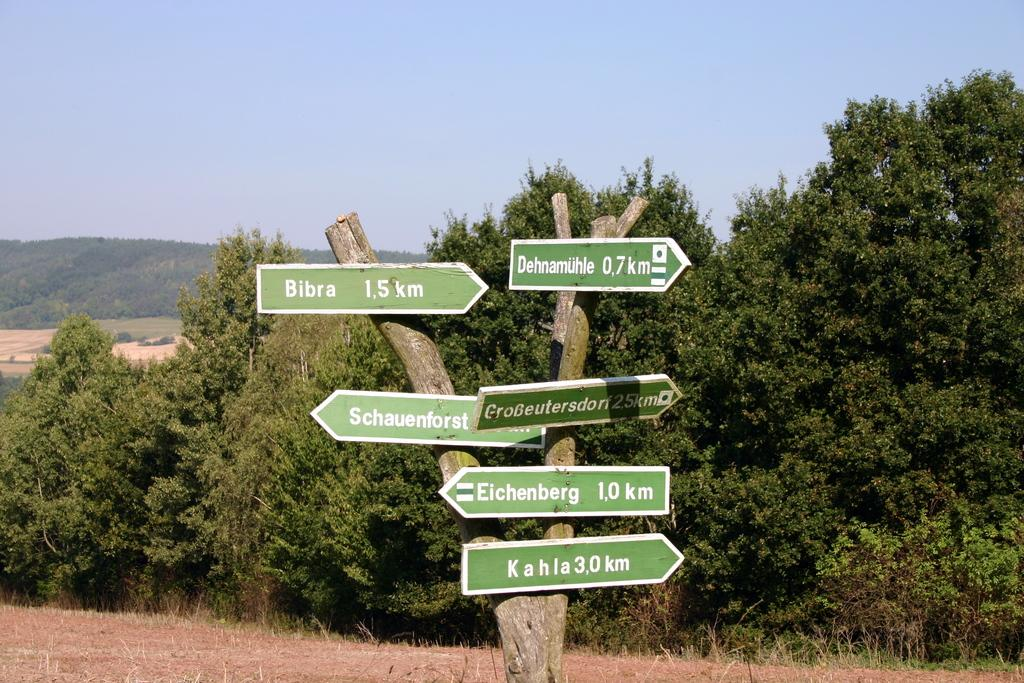<image>
Provide a brief description of the given image. the number 10 is on one of the many green signs 